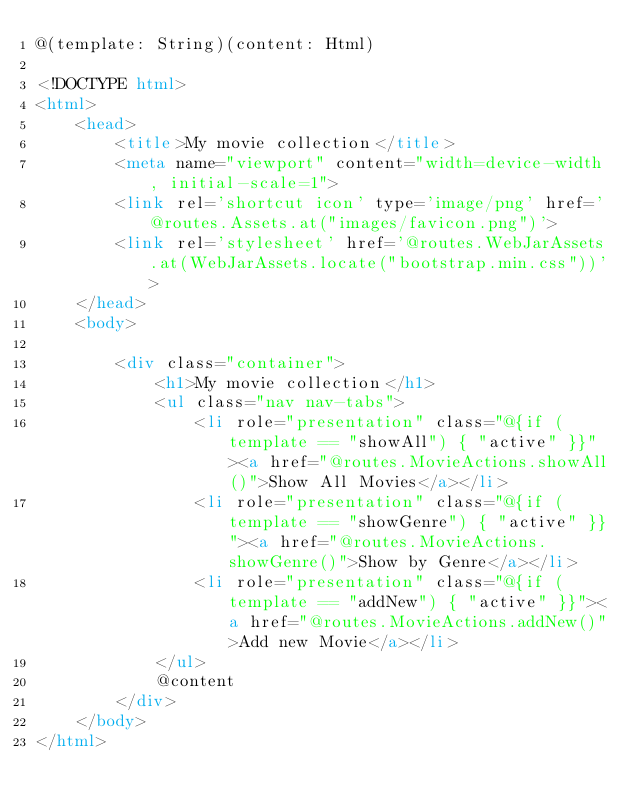<code> <loc_0><loc_0><loc_500><loc_500><_HTML_>@(template: String)(content: Html)

<!DOCTYPE html>
<html>
    <head>
        <title>My movie collection</title>
        <meta name="viewport" content="width=device-width, initial-scale=1">
        <link rel='shortcut icon' type='image/png' href='@routes.Assets.at("images/favicon.png")'>
        <link rel='stylesheet' href='@routes.WebJarAssets.at(WebJarAssets.locate("bootstrap.min.css"))'>
    </head>
    <body>

        <div class="container">
            <h1>My movie collection</h1>
            <ul class="nav nav-tabs">
                <li role="presentation" class="@{if (template == "showAll") { "active" }}"><a href="@routes.MovieActions.showAll()">Show All Movies</a></li>
                <li role="presentation" class="@{if (template == "showGenre") { "active" }}"><a href="@routes.MovieActions.showGenre()">Show by Genre</a></li>
                <li role="presentation" class="@{if (template == "addNew") { "active" }}"><a href="@routes.MovieActions.addNew()">Add new Movie</a></li>
            </ul>
            @content
        </div>
    </body>
</html>
</code> 